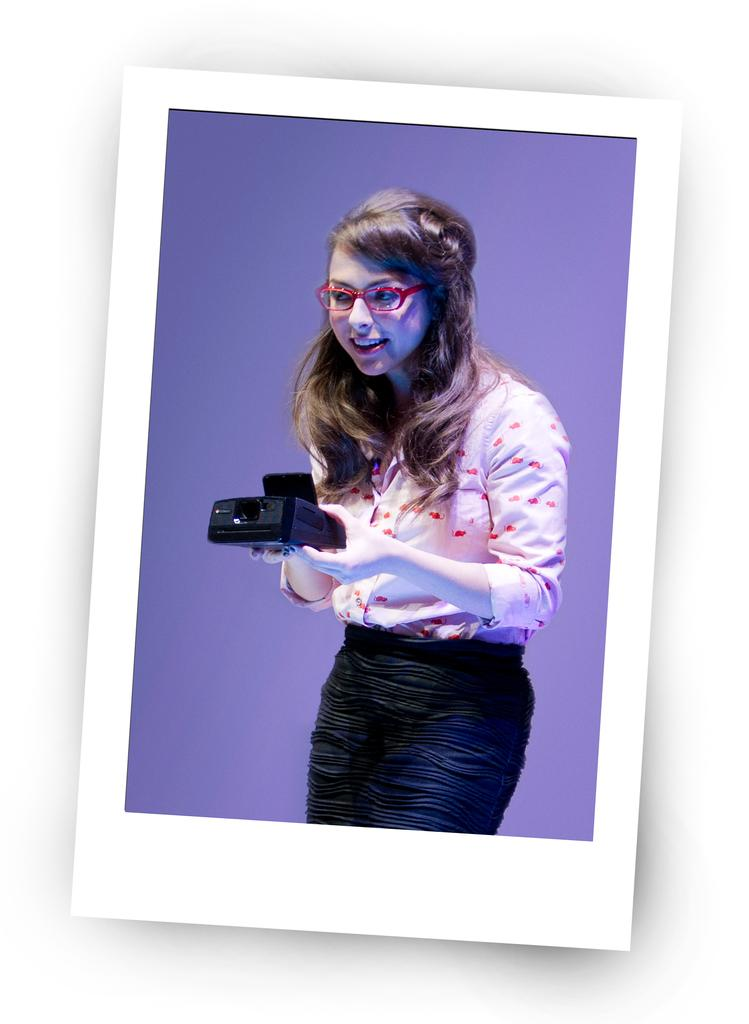What is the main subject of the image? The main subject of the image is a photograph of a lady. What is the lady holding in the photograph? The lady is holding an object. What type of music is the kitty playing on the houses in the image? There is no kitty or houses present in the image, and therefore no such music can be observed. 